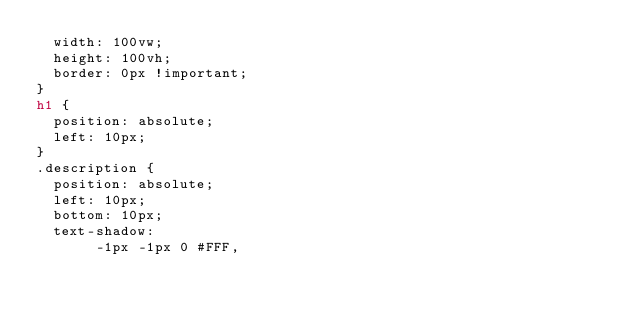Convert code to text. <code><loc_0><loc_0><loc_500><loc_500><_HTML_>  width: 100vw;
  height: 100vh;
  border: 0px !important;
}
h1 {
  position: absolute;
  left: 10px;
}
.description {
  position: absolute;
  left: 10px;
  bottom: 10px;
  text-shadow:
       -1px -1px 0 #FFF,</code> 